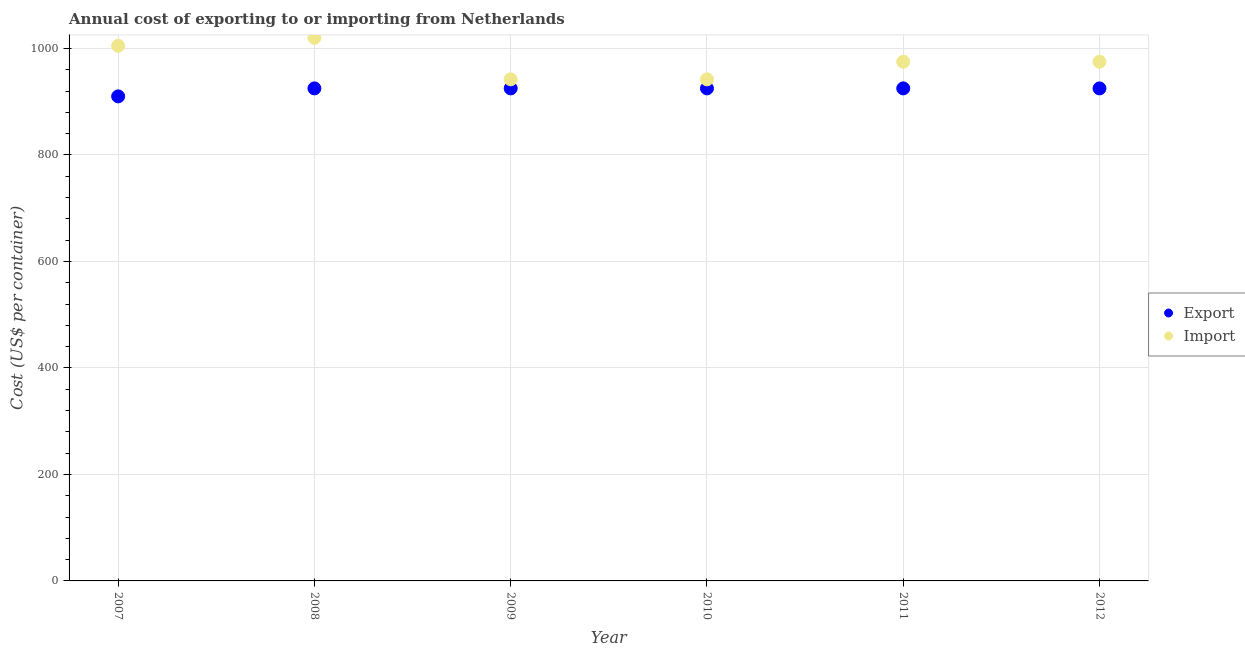How many different coloured dotlines are there?
Provide a succinct answer. 2. What is the import cost in 2007?
Give a very brief answer. 1005. Across all years, what is the maximum import cost?
Your answer should be compact. 1020. Across all years, what is the minimum export cost?
Make the answer very short. 910. In which year was the import cost maximum?
Make the answer very short. 2008. In which year was the export cost minimum?
Provide a succinct answer. 2007. What is the total import cost in the graph?
Provide a succinct answer. 5859. What is the difference between the export cost in 2011 and that in 2012?
Your answer should be very brief. 0. What is the difference between the import cost in 2011 and the export cost in 2010?
Offer a terse response. 50. What is the average export cost per year?
Provide a short and direct response. 922.5. In the year 2007, what is the difference between the import cost and export cost?
Your answer should be compact. 95. What is the difference between the highest and the lowest import cost?
Offer a terse response. 78. Is the sum of the import cost in 2010 and 2012 greater than the maximum export cost across all years?
Your response must be concise. Yes. Is the import cost strictly less than the export cost over the years?
Ensure brevity in your answer.  No. How many dotlines are there?
Your response must be concise. 2. Does the graph contain any zero values?
Your answer should be very brief. No. Does the graph contain grids?
Your answer should be compact. Yes. Where does the legend appear in the graph?
Provide a short and direct response. Center right. How many legend labels are there?
Make the answer very short. 2. What is the title of the graph?
Provide a succinct answer. Annual cost of exporting to or importing from Netherlands. What is the label or title of the Y-axis?
Make the answer very short. Cost (US$ per container). What is the Cost (US$ per container) in Export in 2007?
Offer a very short reply. 910. What is the Cost (US$ per container) in Import in 2007?
Offer a very short reply. 1005. What is the Cost (US$ per container) in Export in 2008?
Make the answer very short. 925. What is the Cost (US$ per container) in Import in 2008?
Your answer should be compact. 1020. What is the Cost (US$ per container) in Export in 2009?
Offer a terse response. 925. What is the Cost (US$ per container) of Import in 2009?
Offer a terse response. 942. What is the Cost (US$ per container) of Export in 2010?
Ensure brevity in your answer.  925. What is the Cost (US$ per container) of Import in 2010?
Provide a short and direct response. 942. What is the Cost (US$ per container) of Export in 2011?
Give a very brief answer. 925. What is the Cost (US$ per container) in Import in 2011?
Ensure brevity in your answer.  975. What is the Cost (US$ per container) in Export in 2012?
Give a very brief answer. 925. What is the Cost (US$ per container) of Import in 2012?
Offer a very short reply. 975. Across all years, what is the maximum Cost (US$ per container) in Export?
Make the answer very short. 925. Across all years, what is the maximum Cost (US$ per container) of Import?
Your answer should be very brief. 1020. Across all years, what is the minimum Cost (US$ per container) of Export?
Your answer should be very brief. 910. Across all years, what is the minimum Cost (US$ per container) of Import?
Your response must be concise. 942. What is the total Cost (US$ per container) of Export in the graph?
Your response must be concise. 5535. What is the total Cost (US$ per container) of Import in the graph?
Your response must be concise. 5859. What is the difference between the Cost (US$ per container) in Import in 2007 and that in 2008?
Provide a succinct answer. -15. What is the difference between the Cost (US$ per container) of Export in 2007 and that in 2009?
Give a very brief answer. -15. What is the difference between the Cost (US$ per container) in Import in 2007 and that in 2009?
Your answer should be compact. 63. What is the difference between the Cost (US$ per container) in Import in 2007 and that in 2010?
Your answer should be very brief. 63. What is the difference between the Cost (US$ per container) of Import in 2007 and that in 2011?
Ensure brevity in your answer.  30. What is the difference between the Cost (US$ per container) in Import in 2007 and that in 2012?
Provide a succinct answer. 30. What is the difference between the Cost (US$ per container) of Import in 2008 and that in 2009?
Keep it short and to the point. 78. What is the difference between the Cost (US$ per container) of Export in 2008 and that in 2010?
Your answer should be very brief. 0. What is the difference between the Cost (US$ per container) in Import in 2008 and that in 2012?
Keep it short and to the point. 45. What is the difference between the Cost (US$ per container) of Export in 2009 and that in 2010?
Provide a short and direct response. 0. What is the difference between the Cost (US$ per container) in Import in 2009 and that in 2010?
Offer a very short reply. 0. What is the difference between the Cost (US$ per container) in Export in 2009 and that in 2011?
Provide a short and direct response. 0. What is the difference between the Cost (US$ per container) of Import in 2009 and that in 2011?
Your answer should be compact. -33. What is the difference between the Cost (US$ per container) in Import in 2009 and that in 2012?
Your answer should be very brief. -33. What is the difference between the Cost (US$ per container) of Import in 2010 and that in 2011?
Your answer should be compact. -33. What is the difference between the Cost (US$ per container) in Export in 2010 and that in 2012?
Your response must be concise. 0. What is the difference between the Cost (US$ per container) of Import in 2010 and that in 2012?
Ensure brevity in your answer.  -33. What is the difference between the Cost (US$ per container) of Export in 2011 and that in 2012?
Provide a succinct answer. 0. What is the difference between the Cost (US$ per container) in Export in 2007 and the Cost (US$ per container) in Import in 2008?
Your answer should be compact. -110. What is the difference between the Cost (US$ per container) of Export in 2007 and the Cost (US$ per container) of Import in 2009?
Keep it short and to the point. -32. What is the difference between the Cost (US$ per container) of Export in 2007 and the Cost (US$ per container) of Import in 2010?
Provide a succinct answer. -32. What is the difference between the Cost (US$ per container) of Export in 2007 and the Cost (US$ per container) of Import in 2011?
Keep it short and to the point. -65. What is the difference between the Cost (US$ per container) of Export in 2007 and the Cost (US$ per container) of Import in 2012?
Give a very brief answer. -65. What is the difference between the Cost (US$ per container) in Export in 2008 and the Cost (US$ per container) in Import in 2009?
Your answer should be very brief. -17. What is the difference between the Cost (US$ per container) of Export in 2008 and the Cost (US$ per container) of Import in 2011?
Provide a short and direct response. -50. What is the difference between the Cost (US$ per container) of Export in 2008 and the Cost (US$ per container) of Import in 2012?
Provide a short and direct response. -50. What is the difference between the Cost (US$ per container) of Export in 2009 and the Cost (US$ per container) of Import in 2011?
Offer a very short reply. -50. What is the difference between the Cost (US$ per container) of Export in 2010 and the Cost (US$ per container) of Import in 2011?
Keep it short and to the point. -50. What is the difference between the Cost (US$ per container) of Export in 2010 and the Cost (US$ per container) of Import in 2012?
Keep it short and to the point. -50. What is the difference between the Cost (US$ per container) of Export in 2011 and the Cost (US$ per container) of Import in 2012?
Offer a terse response. -50. What is the average Cost (US$ per container) in Export per year?
Make the answer very short. 922.5. What is the average Cost (US$ per container) of Import per year?
Your answer should be compact. 976.5. In the year 2007, what is the difference between the Cost (US$ per container) in Export and Cost (US$ per container) in Import?
Give a very brief answer. -95. In the year 2008, what is the difference between the Cost (US$ per container) of Export and Cost (US$ per container) of Import?
Your answer should be compact. -95. In the year 2009, what is the difference between the Cost (US$ per container) in Export and Cost (US$ per container) in Import?
Provide a succinct answer. -17. In the year 2010, what is the difference between the Cost (US$ per container) in Export and Cost (US$ per container) in Import?
Offer a very short reply. -17. In the year 2011, what is the difference between the Cost (US$ per container) in Export and Cost (US$ per container) in Import?
Offer a terse response. -50. In the year 2012, what is the difference between the Cost (US$ per container) in Export and Cost (US$ per container) in Import?
Keep it short and to the point. -50. What is the ratio of the Cost (US$ per container) in Export in 2007 to that in 2008?
Provide a short and direct response. 0.98. What is the ratio of the Cost (US$ per container) of Export in 2007 to that in 2009?
Keep it short and to the point. 0.98. What is the ratio of the Cost (US$ per container) in Import in 2007 to that in 2009?
Make the answer very short. 1.07. What is the ratio of the Cost (US$ per container) of Export in 2007 to that in 2010?
Your answer should be compact. 0.98. What is the ratio of the Cost (US$ per container) of Import in 2007 to that in 2010?
Ensure brevity in your answer.  1.07. What is the ratio of the Cost (US$ per container) of Export in 2007 to that in 2011?
Provide a succinct answer. 0.98. What is the ratio of the Cost (US$ per container) of Import in 2007 to that in 2011?
Your answer should be very brief. 1.03. What is the ratio of the Cost (US$ per container) of Export in 2007 to that in 2012?
Keep it short and to the point. 0.98. What is the ratio of the Cost (US$ per container) in Import in 2007 to that in 2012?
Offer a very short reply. 1.03. What is the ratio of the Cost (US$ per container) of Export in 2008 to that in 2009?
Provide a short and direct response. 1. What is the ratio of the Cost (US$ per container) in Import in 2008 to that in 2009?
Keep it short and to the point. 1.08. What is the ratio of the Cost (US$ per container) in Import in 2008 to that in 2010?
Your response must be concise. 1.08. What is the ratio of the Cost (US$ per container) in Export in 2008 to that in 2011?
Your response must be concise. 1. What is the ratio of the Cost (US$ per container) of Import in 2008 to that in 2011?
Ensure brevity in your answer.  1.05. What is the ratio of the Cost (US$ per container) in Import in 2008 to that in 2012?
Give a very brief answer. 1.05. What is the ratio of the Cost (US$ per container) in Export in 2009 to that in 2011?
Give a very brief answer. 1. What is the ratio of the Cost (US$ per container) in Import in 2009 to that in 2011?
Your answer should be very brief. 0.97. What is the ratio of the Cost (US$ per container) in Export in 2009 to that in 2012?
Ensure brevity in your answer.  1. What is the ratio of the Cost (US$ per container) of Import in 2009 to that in 2012?
Your answer should be very brief. 0.97. What is the ratio of the Cost (US$ per container) in Export in 2010 to that in 2011?
Your response must be concise. 1. What is the ratio of the Cost (US$ per container) of Import in 2010 to that in 2011?
Provide a short and direct response. 0.97. What is the ratio of the Cost (US$ per container) of Export in 2010 to that in 2012?
Your response must be concise. 1. What is the ratio of the Cost (US$ per container) of Import in 2010 to that in 2012?
Provide a succinct answer. 0.97. What is the difference between the highest and the second highest Cost (US$ per container) in Export?
Provide a succinct answer. 0. What is the difference between the highest and the lowest Cost (US$ per container) of Export?
Your response must be concise. 15. What is the difference between the highest and the lowest Cost (US$ per container) of Import?
Your answer should be compact. 78. 